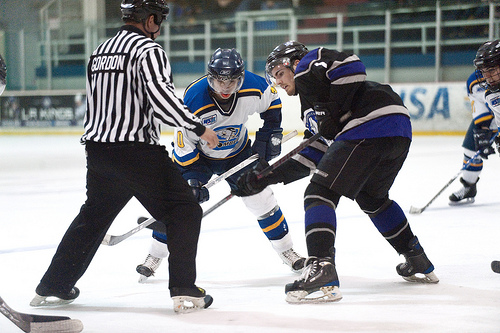<image>
Can you confirm if the player is to the left of the ref? No. The player is not to the left of the ref. From this viewpoint, they have a different horizontal relationship. 